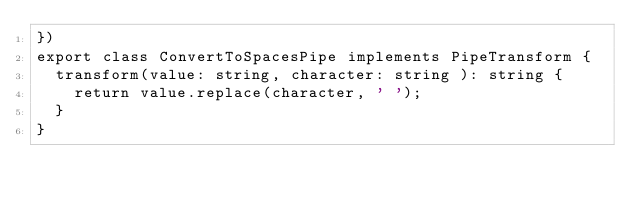<code> <loc_0><loc_0><loc_500><loc_500><_TypeScript_>})
export class ConvertToSpacesPipe implements PipeTransform {
  transform(value: string, character: string ): string {
    return value.replace(character, ' ');
  }
}
</code> 